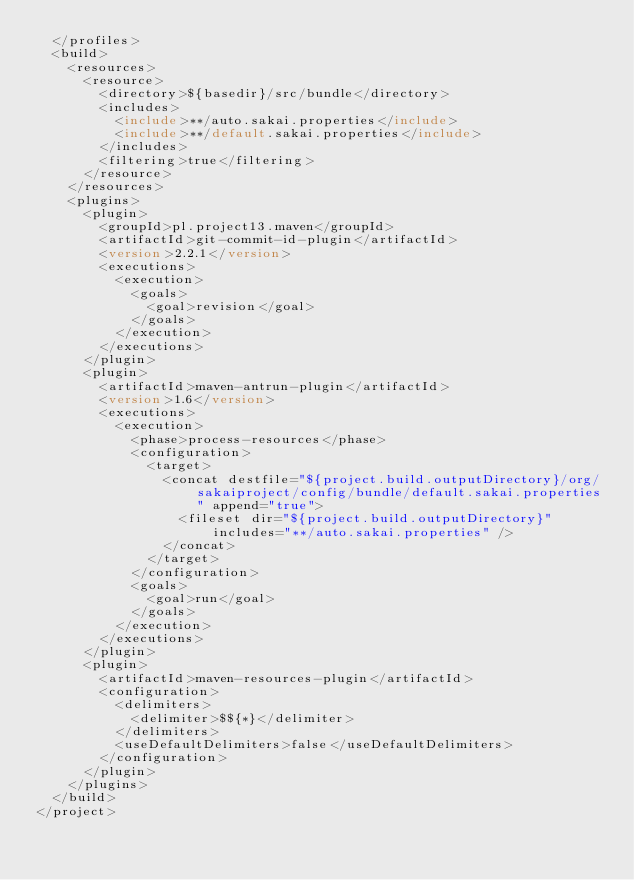<code> <loc_0><loc_0><loc_500><loc_500><_XML_>	</profiles>
	<build>
		<resources>
			<resource>
				<directory>${basedir}/src/bundle</directory>
				<includes>
					<include>**/auto.sakai.properties</include>
					<include>**/default.sakai.properties</include>
				</includes>
				<filtering>true</filtering>
			</resource>
		</resources>
		<plugins>
			<plugin>
				<groupId>pl.project13.maven</groupId>
				<artifactId>git-commit-id-plugin</artifactId>
				<version>2.2.1</version>
				<executions>
					<execution>
						<goals>
							<goal>revision</goal>
						</goals>
					</execution>
				</executions>
			</plugin>
			<plugin>
				<artifactId>maven-antrun-plugin</artifactId>
				<version>1.6</version>
				<executions>
					<execution>
						<phase>process-resources</phase>
						<configuration>
							<target>
								<concat destfile="${project.build.outputDirectory}/org/sakaiproject/config/bundle/default.sakai.properties" append="true">
									<fileset dir="${project.build.outputDirectory}" includes="**/auto.sakai.properties" />
								</concat>
							</target>
						</configuration>
						<goals>
							<goal>run</goal>
						</goals>
					</execution>
				</executions>
			</plugin>
			<plugin>
				<artifactId>maven-resources-plugin</artifactId>
				<configuration>
					<delimiters>
						<delimiter>$${*}</delimiter>
					</delimiters>
					<useDefaultDelimiters>false</useDefaultDelimiters>
				</configuration>
			</plugin>
		</plugins>
	</build>
</project>
</code> 